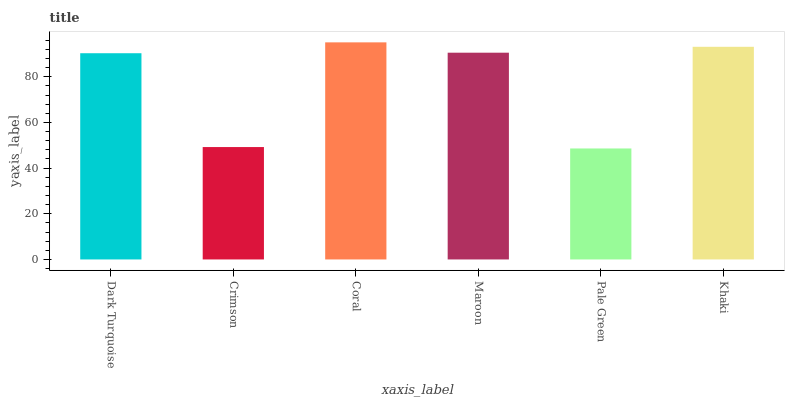Is Pale Green the minimum?
Answer yes or no. Yes. Is Coral the maximum?
Answer yes or no. Yes. Is Crimson the minimum?
Answer yes or no. No. Is Crimson the maximum?
Answer yes or no. No. Is Dark Turquoise greater than Crimson?
Answer yes or no. Yes. Is Crimson less than Dark Turquoise?
Answer yes or no. Yes. Is Crimson greater than Dark Turquoise?
Answer yes or no. No. Is Dark Turquoise less than Crimson?
Answer yes or no. No. Is Maroon the high median?
Answer yes or no. Yes. Is Dark Turquoise the low median?
Answer yes or no. Yes. Is Coral the high median?
Answer yes or no. No. Is Pale Green the low median?
Answer yes or no. No. 